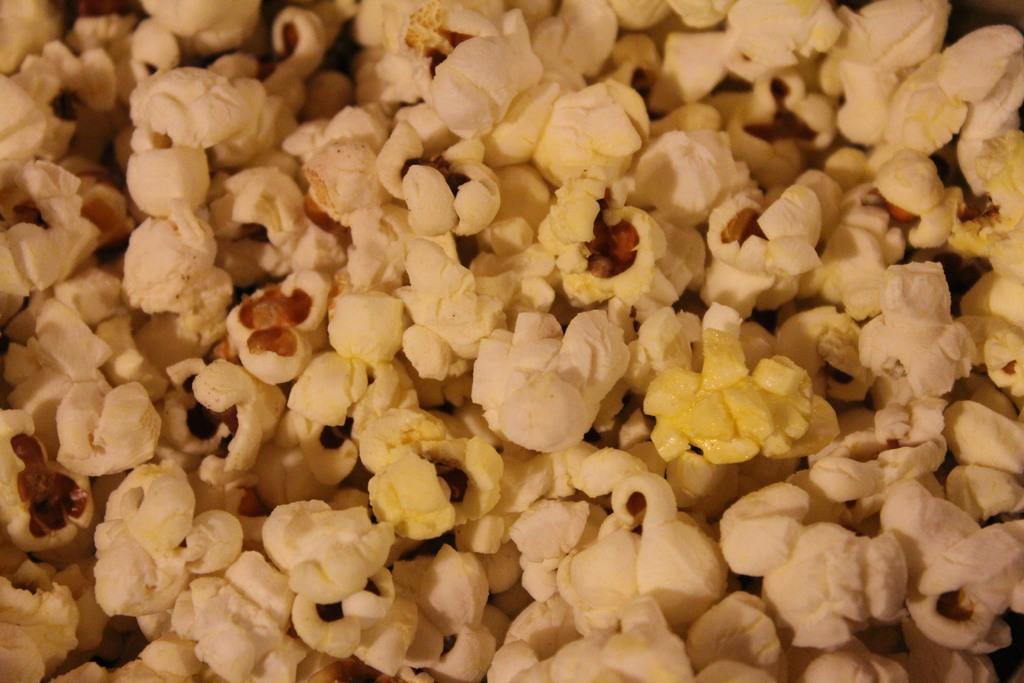Can you describe this image briefly? In this image we can see some popcorn on the surface. 